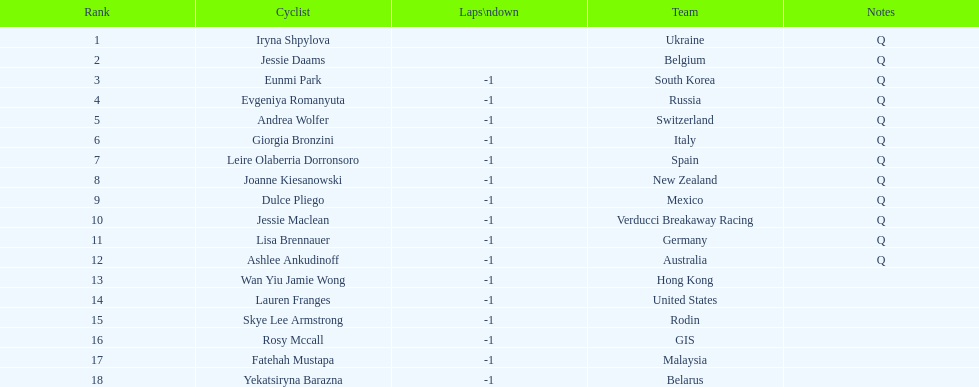What team is listed previous to belgium? Ukraine. 